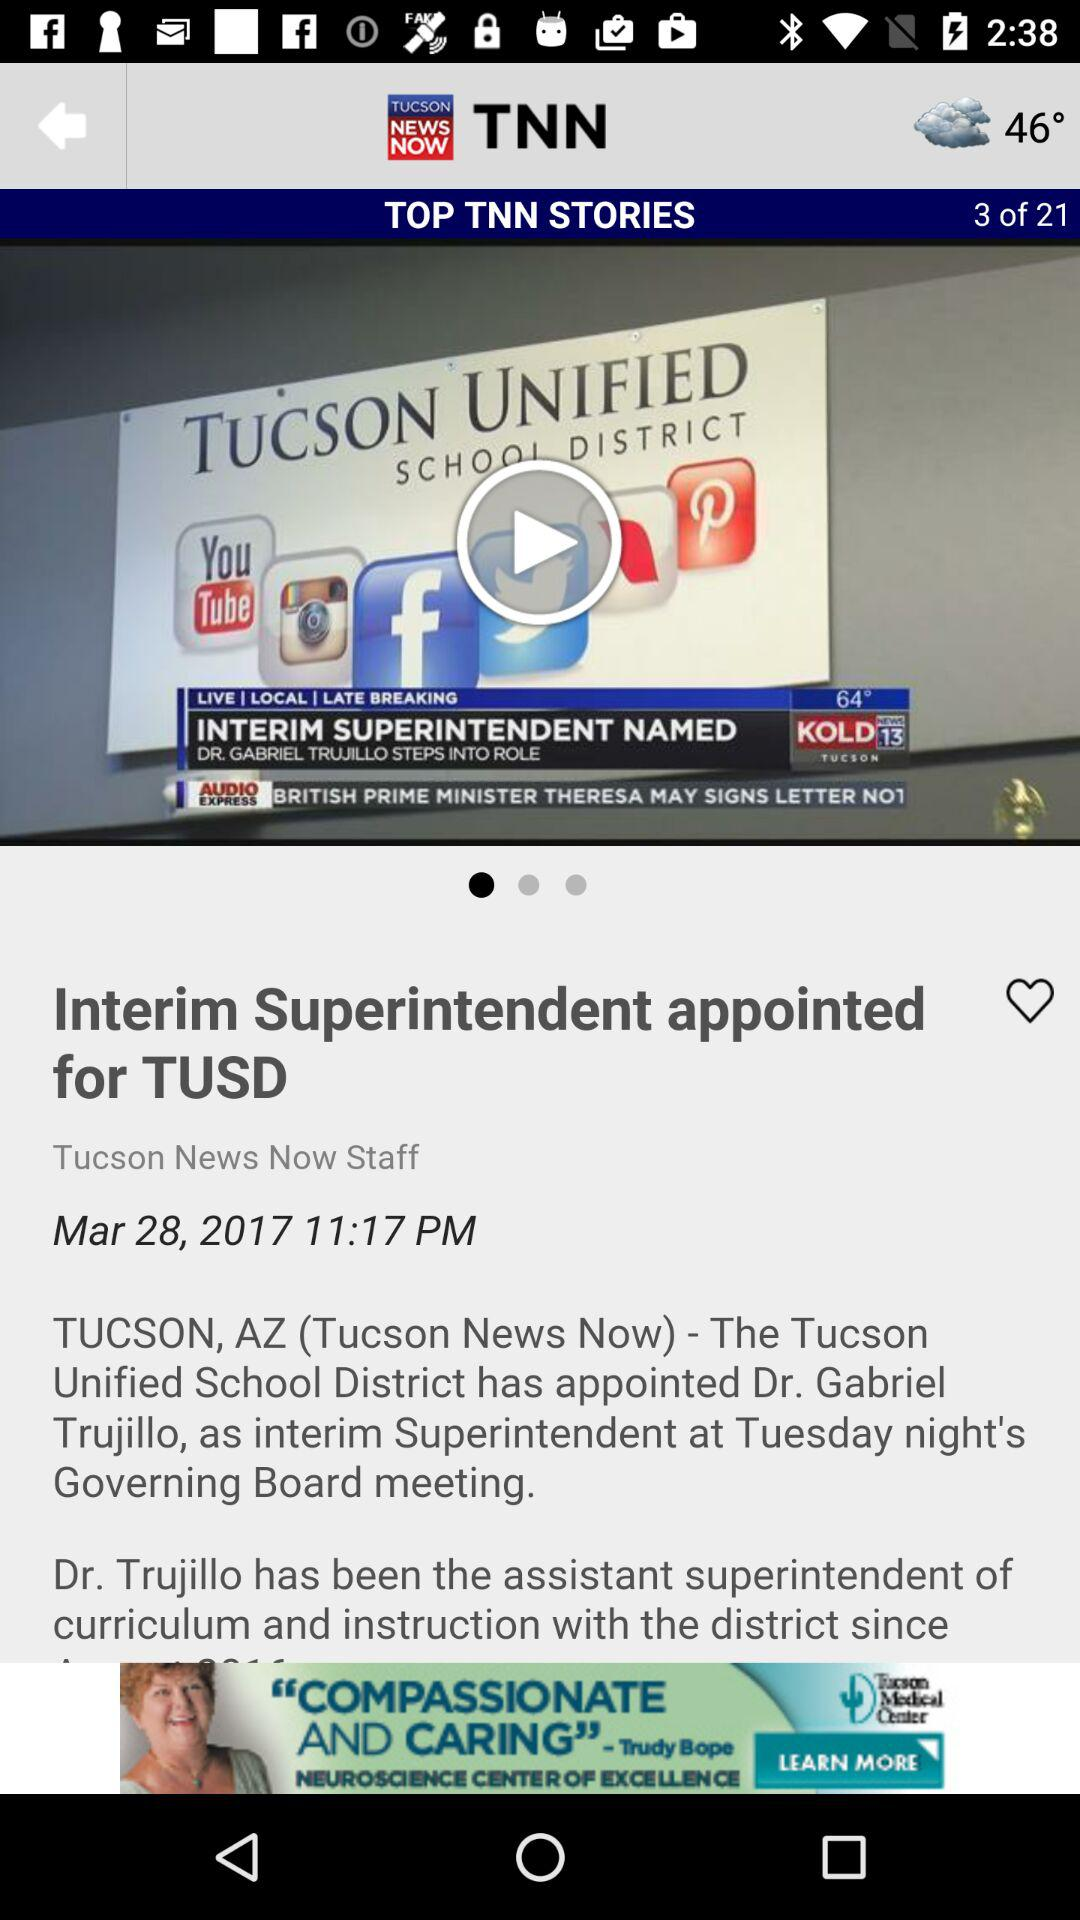What is the posted time of the news? The posted time of the news is 11:17 PM. 